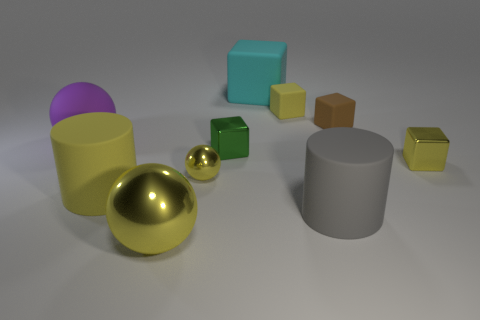There is a yellow matte object that is to the right of the tiny metal sphere; is its shape the same as the small yellow metal object that is on the right side of the brown matte block?
Offer a terse response. Yes. What shape is the large matte thing that is the same color as the large shiny thing?
Make the answer very short. Cylinder. There is a big rubber cylinder on the right side of the yellow object that is in front of the gray object; what is its color?
Ensure brevity in your answer.  Gray. There is another big object that is the same shape as the brown object; what is its color?
Your answer should be very brief. Cyan. What size is the green shiny thing that is the same shape as the small brown matte object?
Your answer should be very brief. Small. There is a cylinder in front of the big yellow matte cylinder; what material is it?
Your answer should be very brief. Rubber. Is the number of large cylinders behind the brown cube less than the number of green shiny balls?
Provide a short and direct response. No. There is a large gray rubber thing on the right side of the yellow matte thing that is in front of the small yellow sphere; what shape is it?
Your answer should be compact. Cylinder. The big rubber block has what color?
Offer a very short reply. Cyan. How many other things are there of the same size as the brown matte object?
Provide a succinct answer. 4. 